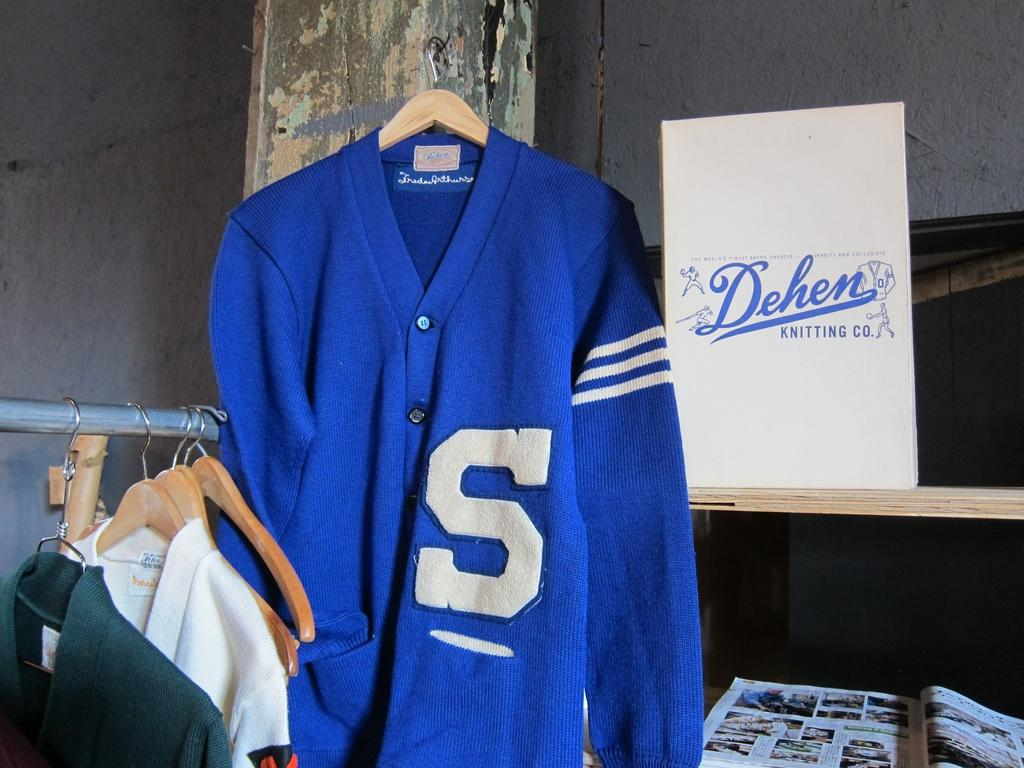<image>
Describe the image concisely. A shirt on a hanger which has the letter S on it. 